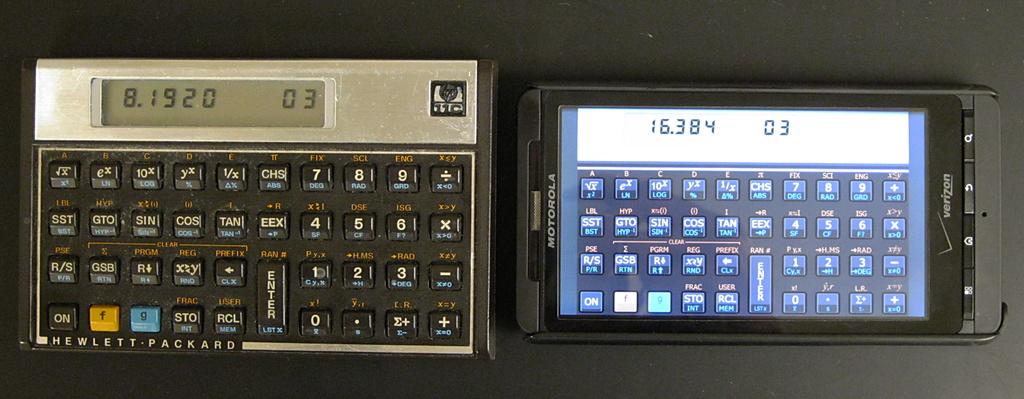What brand of phone?
Offer a very short reply. Motorola. What is on the calculator display?
Make the answer very short. 8.1920 03. 